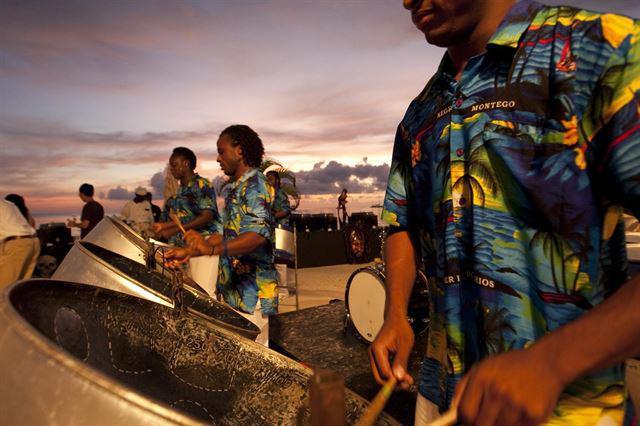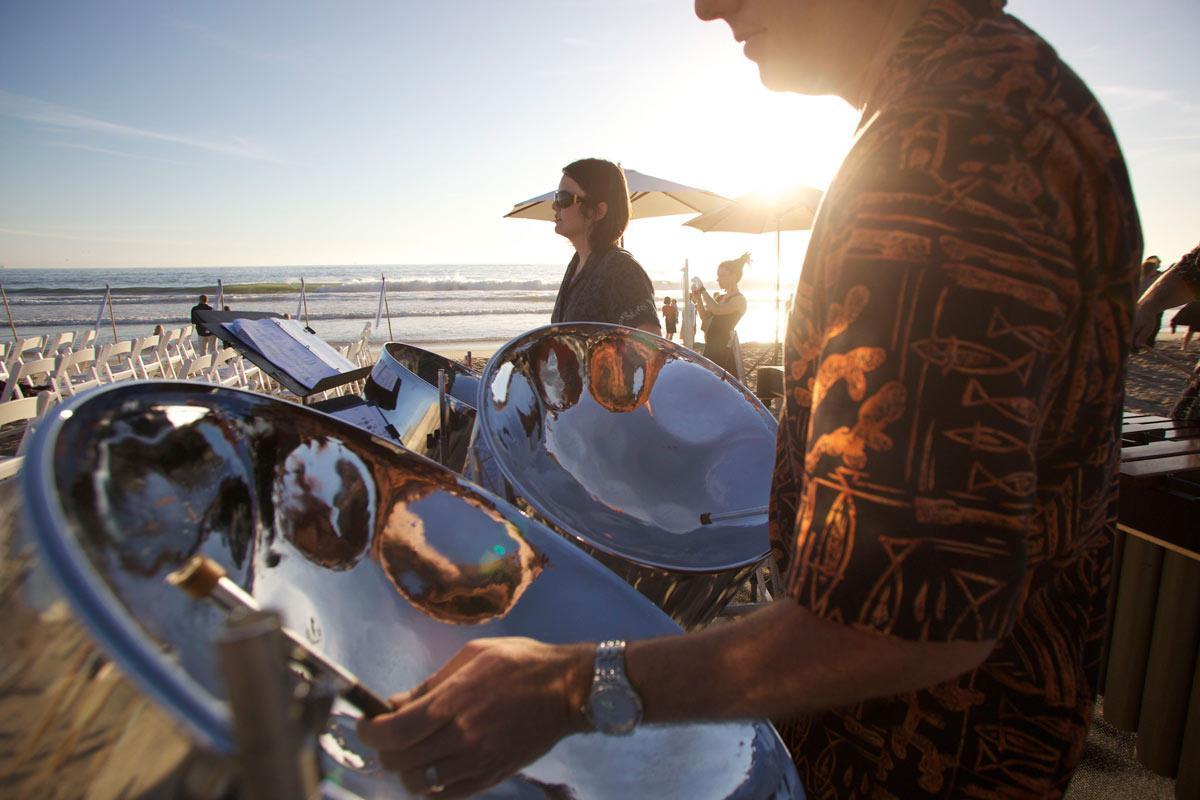The first image is the image on the left, the second image is the image on the right. Assess this claim about the two images: "One man with long braids wearing a blue hawaiian shirt is playing stainless steel bowl-shaped drums in the right image.". Correct or not? Answer yes or no. No. The first image is the image on the left, the second image is the image on the right. For the images displayed, is the sentence "The drummer in the image on the right is wearing a blue and white shirt." factually correct? Answer yes or no. No. 